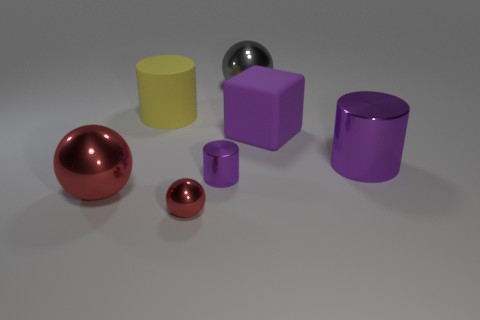Add 2 metal objects. How many objects exist? 9 Subtract all cylinders. How many objects are left? 4 Subtract all purple cylinders. Subtract all purple objects. How many objects are left? 2 Add 1 rubber objects. How many rubber objects are left? 3 Add 3 metal spheres. How many metal spheres exist? 6 Subtract 1 gray balls. How many objects are left? 6 